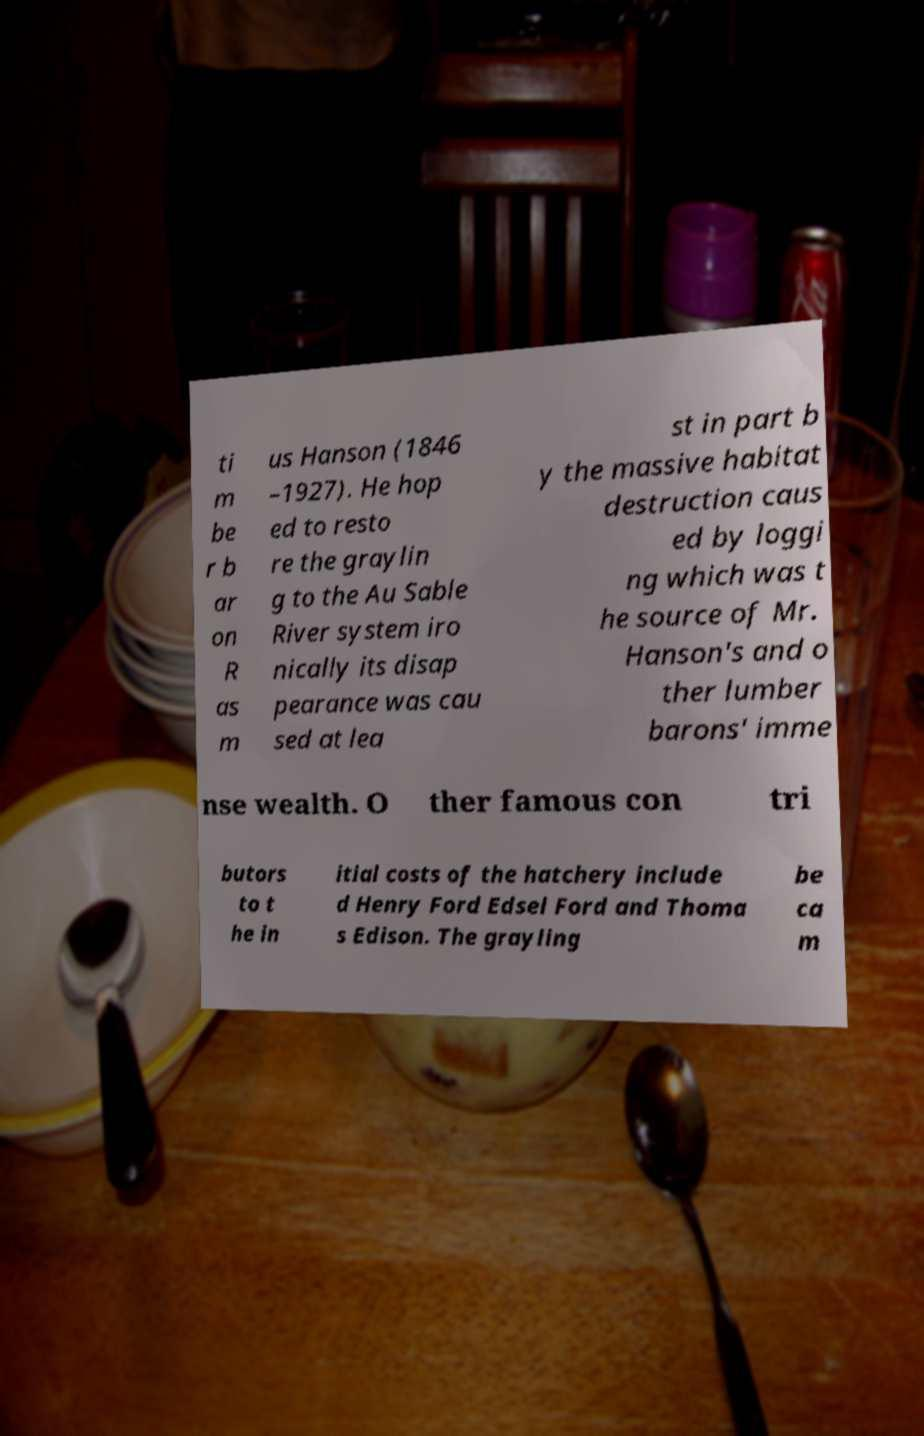There's text embedded in this image that I need extracted. Can you transcribe it verbatim? ti m be r b ar on R as m us Hanson (1846 –1927). He hop ed to resto re the graylin g to the Au Sable River system iro nically its disap pearance was cau sed at lea st in part b y the massive habitat destruction caus ed by loggi ng which was t he source of Mr. Hanson's and o ther lumber barons' imme nse wealth. O ther famous con tri butors to t he in itial costs of the hatchery include d Henry Ford Edsel Ford and Thoma s Edison. The grayling be ca m 